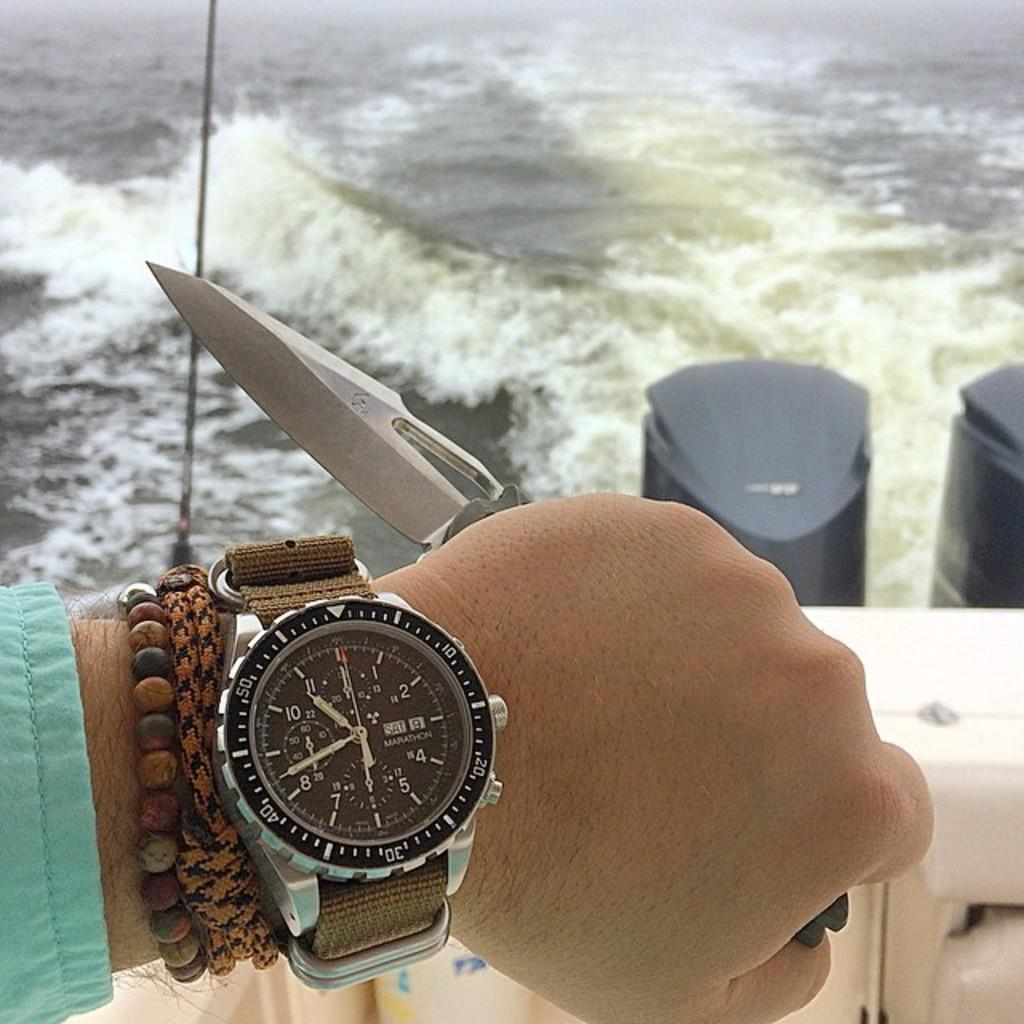<image>
Create a compact narrative representing the image presented. A person is showing their Marathon watch which is displaying the time. 